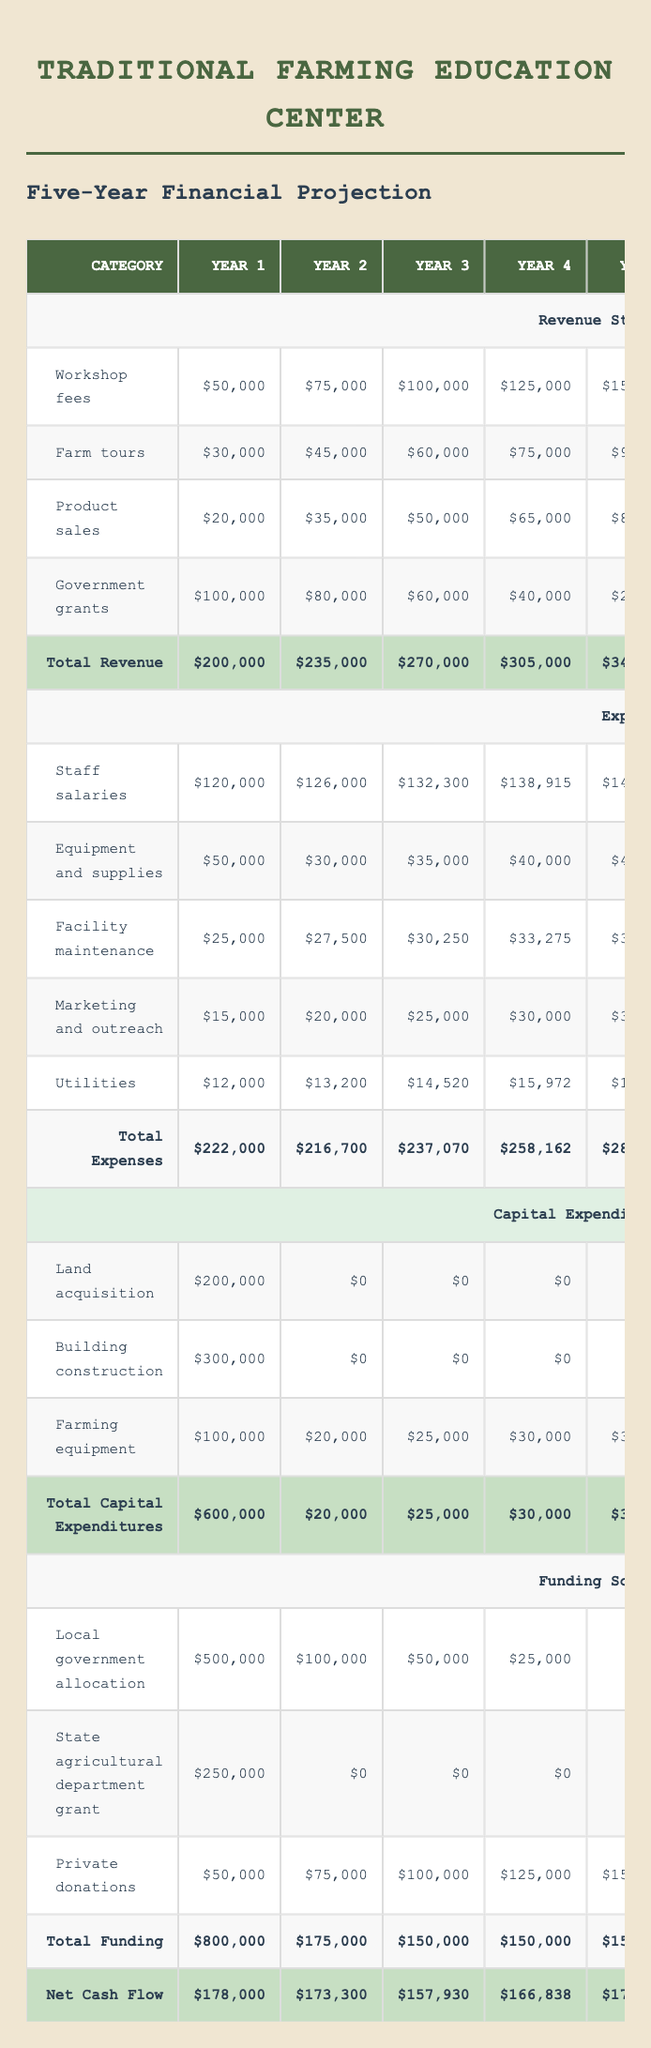What is the total revenue in Year 3? To find the total revenue for Year 3, we need to sum the revenue from all sources for that year. The values for Year 3 are: Workshop fees: 100000, Farm tours: 60000, Product sales: 50000, Government grants: 60000. Adding these gives: 100000 + 60000 + 50000 + 60000 = 270000.
Answer: 270000 What is the total expense in Year 1? The total expense for Year 1 is calculated by summing the individual expenses listed for that year. The expenses are: Staff salaries: 120000, Equipment and supplies: 50000, Facility maintenance: 25000, Marketing and outreach: 15000, Utilities: 12000. Thus, 120000 + 50000 + 25000 + 15000 + 12000 = 222000.
Answer: 222000 Is the funding from the local government allocation decreasing or increasing over the five years? To determine the trend in funding from the local government allocation, we check the values: Year 1: 500000, Year 2: 100000, Year 3: 50000, Year 4: 25000, Year 5: 0. It is clear that the amounts are decreasing each year.
Answer: Yes What is the average net cash flow over five years? To calculate the average net cash flow, we sum the net cash flow values across all five years and then divide by 5. The net cash flow values are: Year 1: 178000, Year 2: 173300, Year 3: 157930, Year 4: 166838, Year 5: 174967. Thus, the sum is 178000 + 173300 + 157930 + 166838 + 174967 = 850035. The average is 850035 / 5 = 170007.
Answer: 170007 What is the difference between total revenue and total expenses in Year 5? To find the difference between total revenue and total expenses in Year 5, we need to subtract the total expenses from the total revenue for that year. Total revenue in Year 5 is 340000, and total expenses are 280033. Thus, the difference is 340000 - 280033 = 59967.
Answer: 59967 Are the equipment and supplies expenses higher than staff salaries in Year 2? From the table, we find the expenses for Year 2: Equipment and supplies: 30000, Staff salaries: 126000. Since 30000 is less than 126000, the answer is no.
Answer: No What is the total capital expenditures for Year 1? To find the total capital expenditures for Year 1, we sum the individual amounts: Land acquisition: 200000, Building construction: 300000, Farming equipment: 100000. Thus, the total is 200000 + 300000 + 100000 = 600000.
Answer: 600000 What is the trend of product sales revenue over the five years? We examine the values for product sales across the years: Year 1: 20000, Year 2: 35000, Year 3: 50000, Year 4: 65000, Year 5: 80000. Each year shows an increase, indicating a growing trend in product sales revenue.
Answer: Increasing 